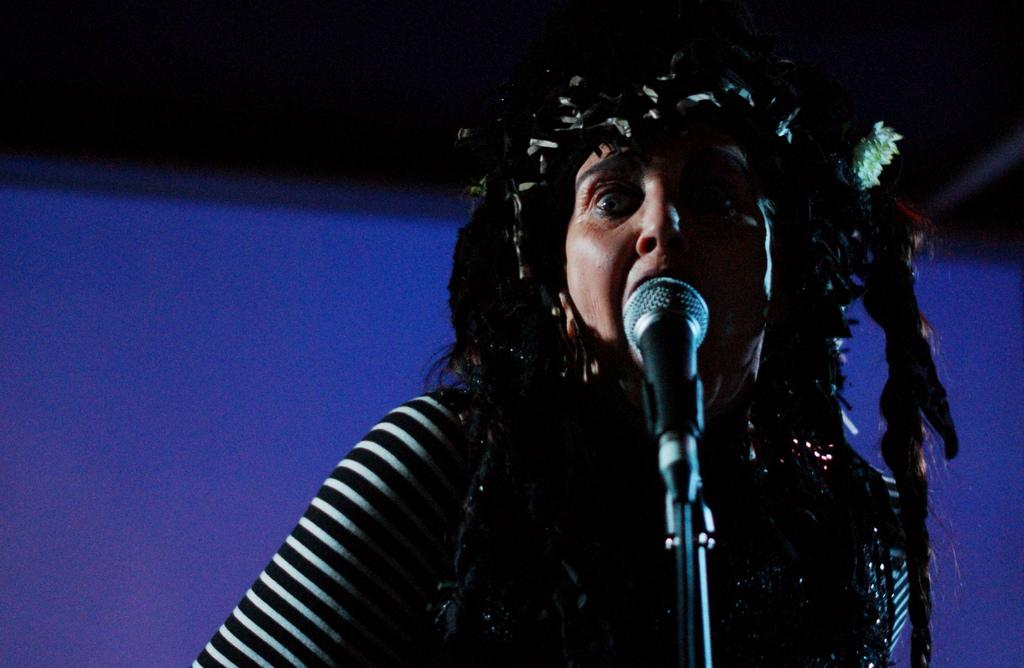What is the main subject of the image? There is a person in the image. What object is the person using in the image? There is a microphone (mike) in the image. What is the microphone attached to in the image? There is a microphone stand in the image. Can you describe the background of the image? The background of the image is blurred. What type of print can be seen on the canvas in the image? There is no print or canvas present in the image. 